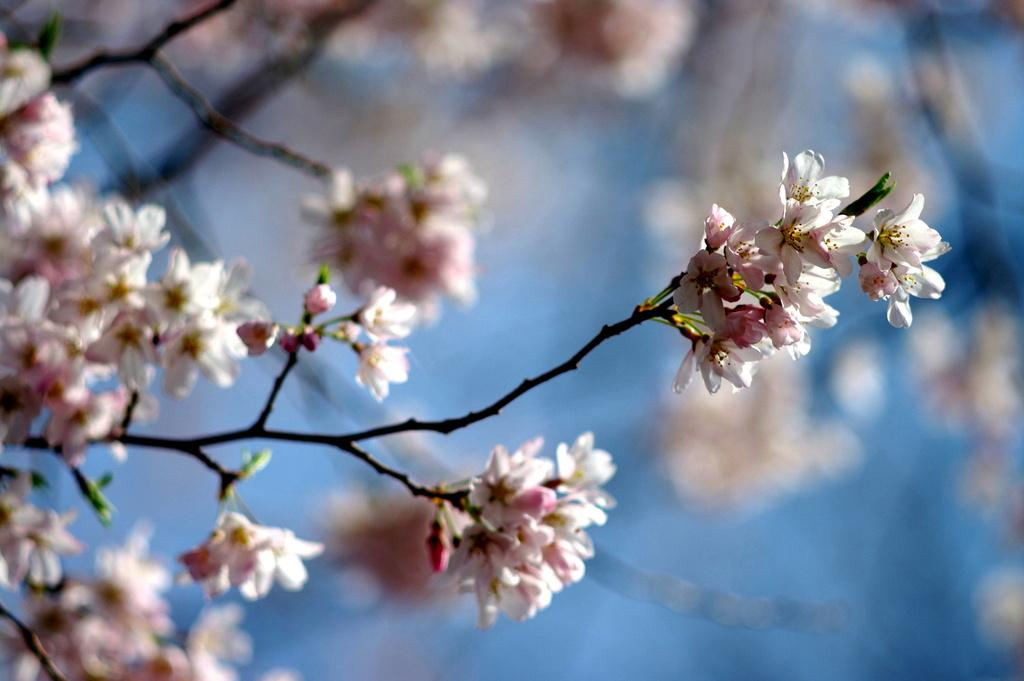What type of flowers can be seen in the image? There are small white color flowers in the image. What type of pin is used to hold the flowers in the image? There is no pin present in the image; the flowers are not being held by any pin. Where is the office located in the image? There is no office present in the image; it only features small white color flowers. 